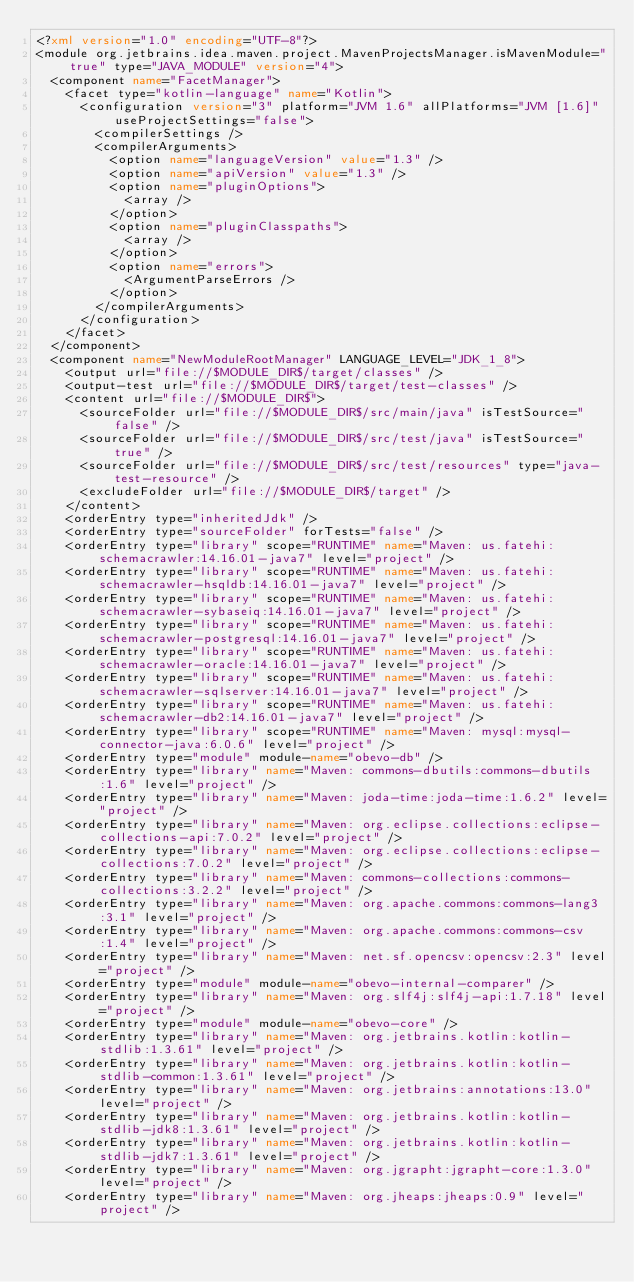<code> <loc_0><loc_0><loc_500><loc_500><_XML_><?xml version="1.0" encoding="UTF-8"?>
<module org.jetbrains.idea.maven.project.MavenProjectsManager.isMavenModule="true" type="JAVA_MODULE" version="4">
  <component name="FacetManager">
    <facet type="kotlin-language" name="Kotlin">
      <configuration version="3" platform="JVM 1.6" allPlatforms="JVM [1.6]" useProjectSettings="false">
        <compilerSettings />
        <compilerArguments>
          <option name="languageVersion" value="1.3" />
          <option name="apiVersion" value="1.3" />
          <option name="pluginOptions">
            <array />
          </option>
          <option name="pluginClasspaths">
            <array />
          </option>
          <option name="errors">
            <ArgumentParseErrors />
          </option>
        </compilerArguments>
      </configuration>
    </facet>
  </component>
  <component name="NewModuleRootManager" LANGUAGE_LEVEL="JDK_1_8">
    <output url="file://$MODULE_DIR$/target/classes" />
    <output-test url="file://$MODULE_DIR$/target/test-classes" />
    <content url="file://$MODULE_DIR$">
      <sourceFolder url="file://$MODULE_DIR$/src/main/java" isTestSource="false" />
      <sourceFolder url="file://$MODULE_DIR$/src/test/java" isTestSource="true" />
      <sourceFolder url="file://$MODULE_DIR$/src/test/resources" type="java-test-resource" />
      <excludeFolder url="file://$MODULE_DIR$/target" />
    </content>
    <orderEntry type="inheritedJdk" />
    <orderEntry type="sourceFolder" forTests="false" />
    <orderEntry type="library" scope="RUNTIME" name="Maven: us.fatehi:schemacrawler:14.16.01-java7" level="project" />
    <orderEntry type="library" scope="RUNTIME" name="Maven: us.fatehi:schemacrawler-hsqldb:14.16.01-java7" level="project" />
    <orderEntry type="library" scope="RUNTIME" name="Maven: us.fatehi:schemacrawler-sybaseiq:14.16.01-java7" level="project" />
    <orderEntry type="library" scope="RUNTIME" name="Maven: us.fatehi:schemacrawler-postgresql:14.16.01-java7" level="project" />
    <orderEntry type="library" scope="RUNTIME" name="Maven: us.fatehi:schemacrawler-oracle:14.16.01-java7" level="project" />
    <orderEntry type="library" scope="RUNTIME" name="Maven: us.fatehi:schemacrawler-sqlserver:14.16.01-java7" level="project" />
    <orderEntry type="library" scope="RUNTIME" name="Maven: us.fatehi:schemacrawler-db2:14.16.01-java7" level="project" />
    <orderEntry type="library" scope="RUNTIME" name="Maven: mysql:mysql-connector-java:6.0.6" level="project" />
    <orderEntry type="module" module-name="obevo-db" />
    <orderEntry type="library" name="Maven: commons-dbutils:commons-dbutils:1.6" level="project" />
    <orderEntry type="library" name="Maven: joda-time:joda-time:1.6.2" level="project" />
    <orderEntry type="library" name="Maven: org.eclipse.collections:eclipse-collections-api:7.0.2" level="project" />
    <orderEntry type="library" name="Maven: org.eclipse.collections:eclipse-collections:7.0.2" level="project" />
    <orderEntry type="library" name="Maven: commons-collections:commons-collections:3.2.2" level="project" />
    <orderEntry type="library" name="Maven: org.apache.commons:commons-lang3:3.1" level="project" />
    <orderEntry type="library" name="Maven: org.apache.commons:commons-csv:1.4" level="project" />
    <orderEntry type="library" name="Maven: net.sf.opencsv:opencsv:2.3" level="project" />
    <orderEntry type="module" module-name="obevo-internal-comparer" />
    <orderEntry type="library" name="Maven: org.slf4j:slf4j-api:1.7.18" level="project" />
    <orderEntry type="module" module-name="obevo-core" />
    <orderEntry type="library" name="Maven: org.jetbrains.kotlin:kotlin-stdlib:1.3.61" level="project" />
    <orderEntry type="library" name="Maven: org.jetbrains.kotlin:kotlin-stdlib-common:1.3.61" level="project" />
    <orderEntry type="library" name="Maven: org.jetbrains:annotations:13.0" level="project" />
    <orderEntry type="library" name="Maven: org.jetbrains.kotlin:kotlin-stdlib-jdk8:1.3.61" level="project" />
    <orderEntry type="library" name="Maven: org.jetbrains.kotlin:kotlin-stdlib-jdk7:1.3.61" level="project" />
    <orderEntry type="library" name="Maven: org.jgrapht:jgrapht-core:1.3.0" level="project" />
    <orderEntry type="library" name="Maven: org.jheaps:jheaps:0.9" level="project" /></code> 